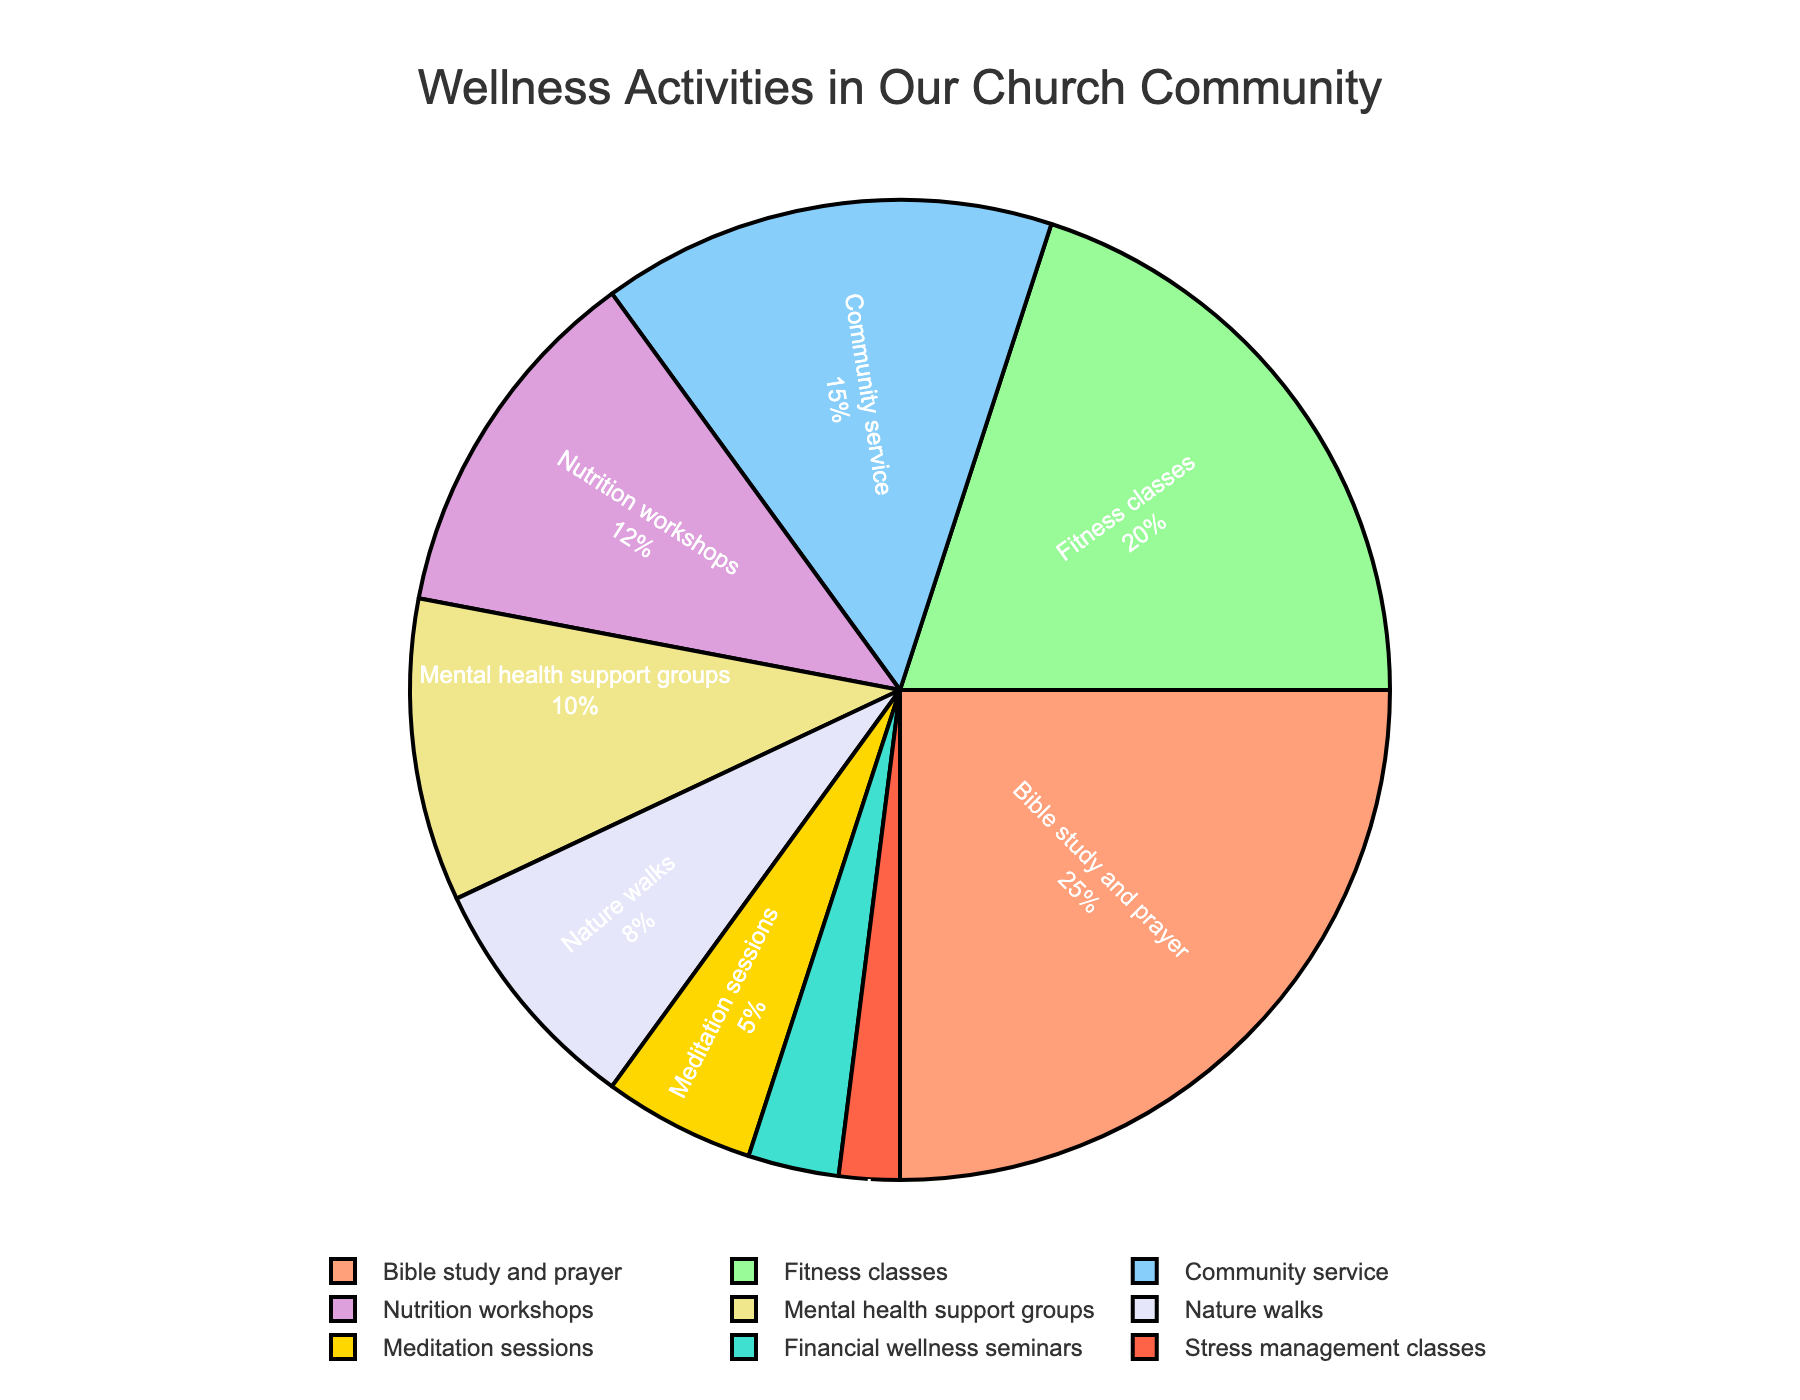What percentage of the church community prefers Fitness classes? Referring to the pie chart, the percentage segment labeled for Fitness classes can be seen.
Answer: 20% Which wellness activity has the least preference in the church community? By looking for the smallest segment in the pie chart, we see that Stress management classes have the least preference.
Answer: Stress management classes What is the combined percentage of Bible study and prayer and Nutrition workshops? The percentages for Bible study and prayer (25%) and Nutrition workshops (12%) can be added together for the combined percentage: 25 + 12 = 37%.
Answer: 37% Are Mental health support groups more popular than Community service? By comparing the percentages in the pie chart, Mental health support groups (10%) have a smaller segment than Community service (15%).
Answer: No Which activities share the color green in the pie chart? Visually identifying the segments colored green in the pie chart reveals that Fitness classes share this color.
Answer: Fitness classes What is the difference in percentage between Nature walks and Meditation sessions? The percentage for Nature walks is 8% and for Meditation sessions it is 5%. The difference can be calculated as 8 - 5 = 3%.
Answer: 3% Are Fitness classes and Community service together more popular than Bible study and prayer? Adding the percentages for Fitness classes (20%) and Community service (15%) gives 35%. Comparing this to Bible study and prayer's 25%, 35% is indeed greater.
Answer: Yes What is the total percentage of activities preferred by at least 10% of the community? Summing up the percentages of activities with at least 10%: Bible study and prayer (25%), Fitness classes (20%), Community service (15%), and Nutrition workshops (12%). Adding them: 25 + 20 + 15 + 12 = 72%.
Answer: 72% Which activity has a slightly greater percentage than Meditation sessions? Identifying the segments around Meditation sessions' 5%, we see that Nature walks have a slightly higher percentage at 8%.
Answer: Nature walks 